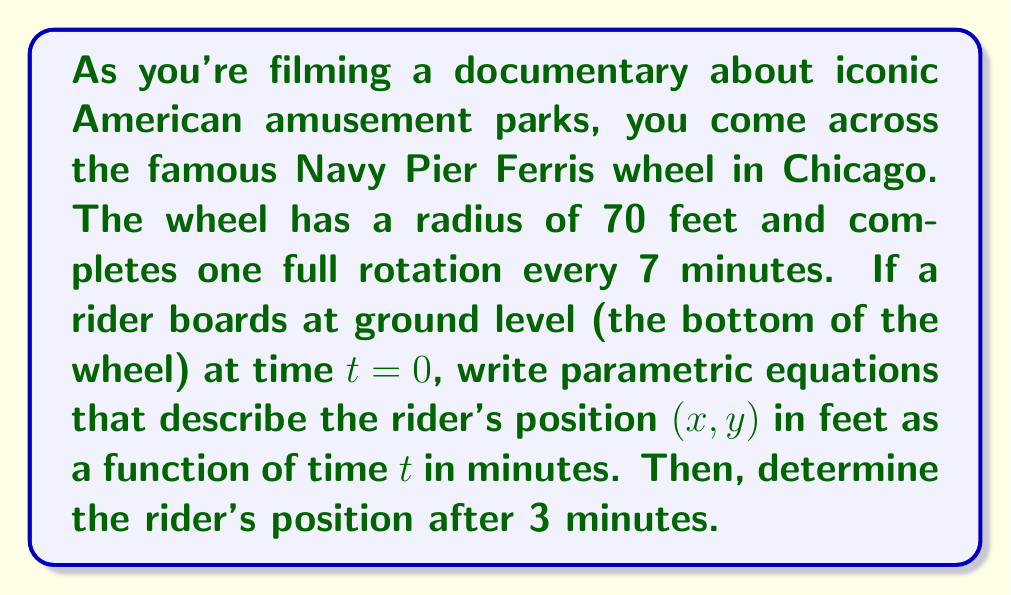Help me with this question. Let's break this down step-by-step:

1) First, we need to set up our coordinate system. Let's place the center of the Ferris wheel at the origin (0, 0), with the positive y-axis pointing up and the positive x-axis pointing to the right.

2) The parametric equations for a circle with radius r are typically:

   $$x = r \cos(\theta)$$
   $$y = r \sin(\theta) + r$$

   We add r to y to start the rider at the bottom of the wheel.

3) In this case, r = 70 feet. We need to express θ in terms of t.

4) The wheel makes a complete rotation (2π radians) every 7 minutes. So the angular velocity ω is:

   $$\omega = \frac{2\pi}{7} \text{ radians/minute}$$

5) The angle θ at time t is thus:

   $$\theta = \omega t = \frac{2\pi}{7}t$$

6) Substituting into our equations:

   $$x = 70 \cos(\frac{2\pi}{7}t)$$
   $$y = 70 \sin(\frac{2\pi}{7}t) + 70$$

7) These are our parametric equations describing the rider's position as a function of time.

8) To find the position after 3 minutes, we substitute t = 3 into these equations:

   $$x = 70 \cos(\frac{2\pi}{7}(3)) \approx -61.07$$
   $$y = 70 \sin(\frac{2\pi}{7}(3)) + 70 \approx 104.89$$

9) Therefore, after 3 minutes, the rider is approximately at position (-61.07, 104.89) feet.
Answer: Parametric equations: $x = 70 \cos(\frac{2\pi}{7}t)$, $y = 70 \sin(\frac{2\pi}{7}t) + 70$

Position after 3 minutes: (-61.07, 104.89) feet 